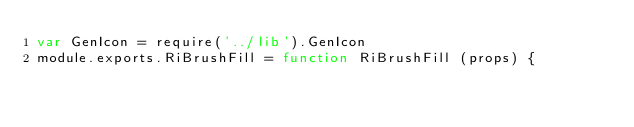<code> <loc_0><loc_0><loc_500><loc_500><_JavaScript_>var GenIcon = require('../lib').GenIcon
module.exports.RiBrushFill = function RiBrushFill (props) {</code> 